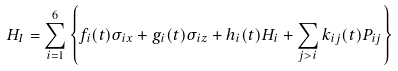<formula> <loc_0><loc_0><loc_500><loc_500>H _ { I } = \sum _ { i = 1 } ^ { 6 } \left \{ f _ { i } ( t ) \sigma _ { i x } + g _ { i } ( t ) \sigma _ { i z } + h _ { i } ( t ) H _ { i } + \sum _ { j > i } k _ { i j } ( t ) P _ { i j } \right \}</formula> 